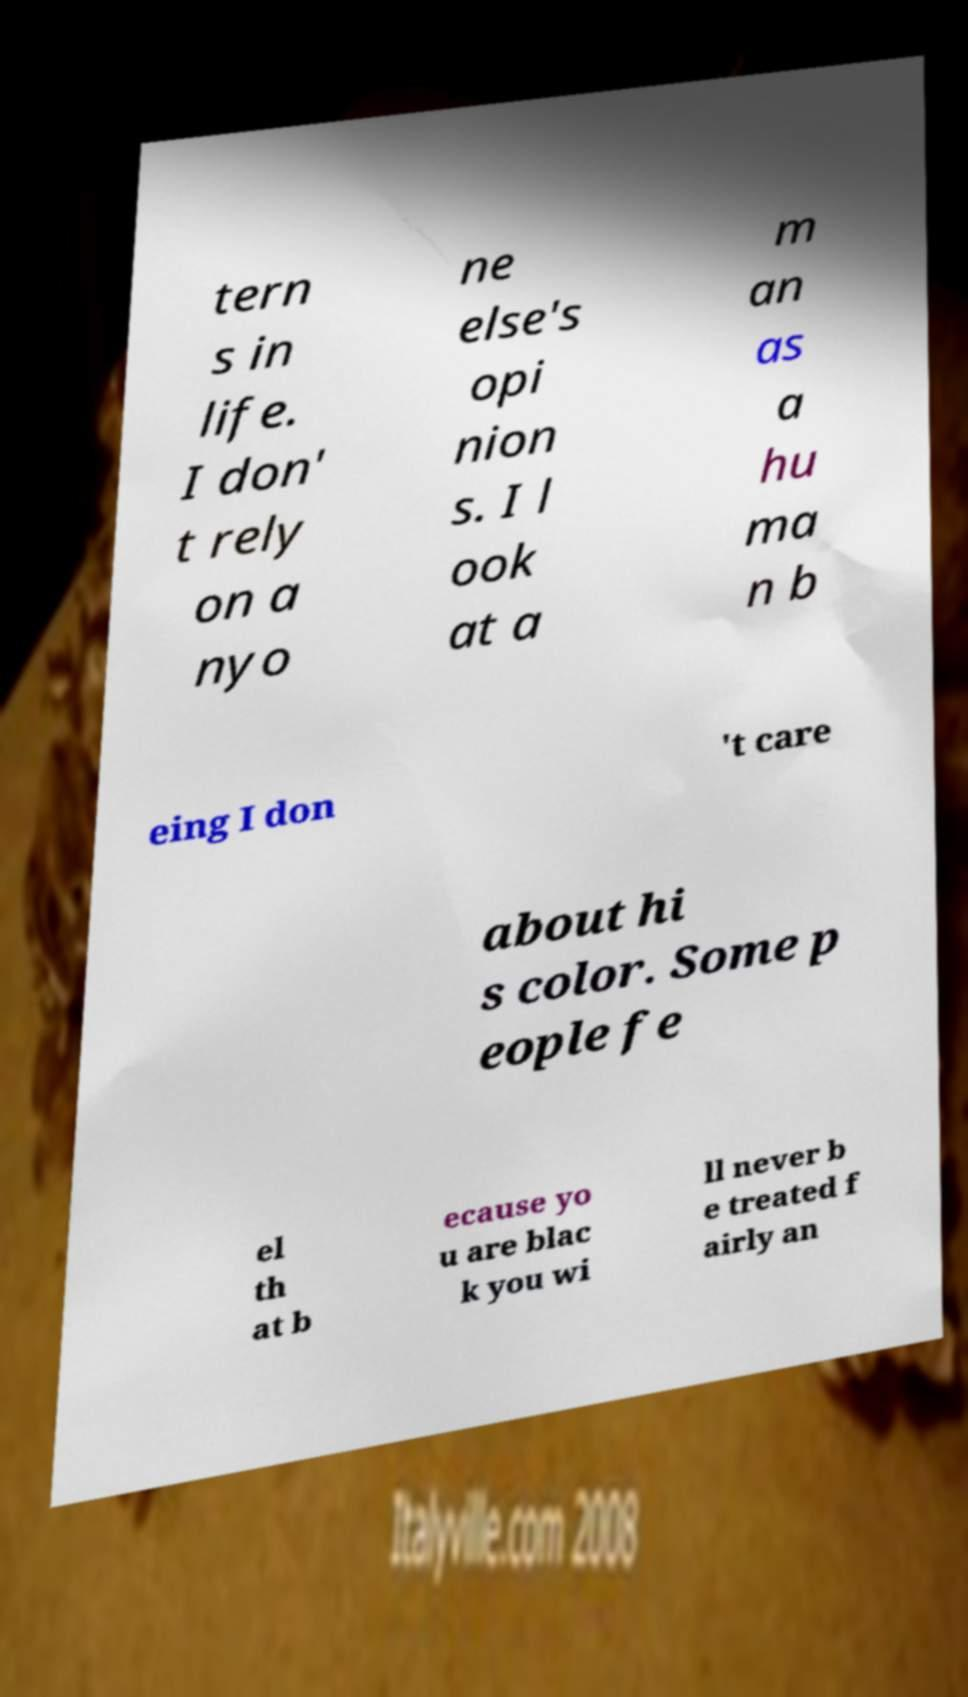Could you extract and type out the text from this image? tern s in life. I don' t rely on a nyo ne else's opi nion s. I l ook at a m an as a hu ma n b eing I don 't care about hi s color. Some p eople fe el th at b ecause yo u are blac k you wi ll never b e treated f airly an 